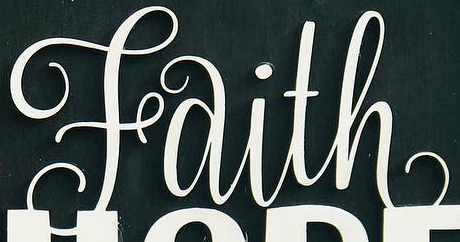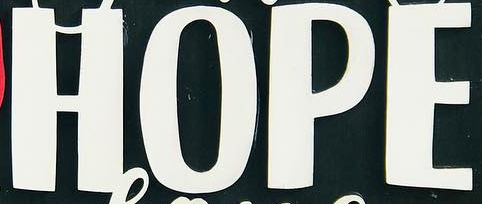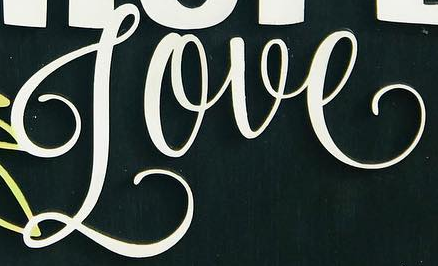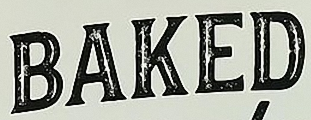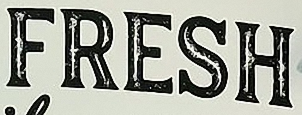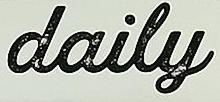Identify the words shown in these images in order, separated by a semicolon. Faith; HOPE; Love; BAKED; FRESH; daily 